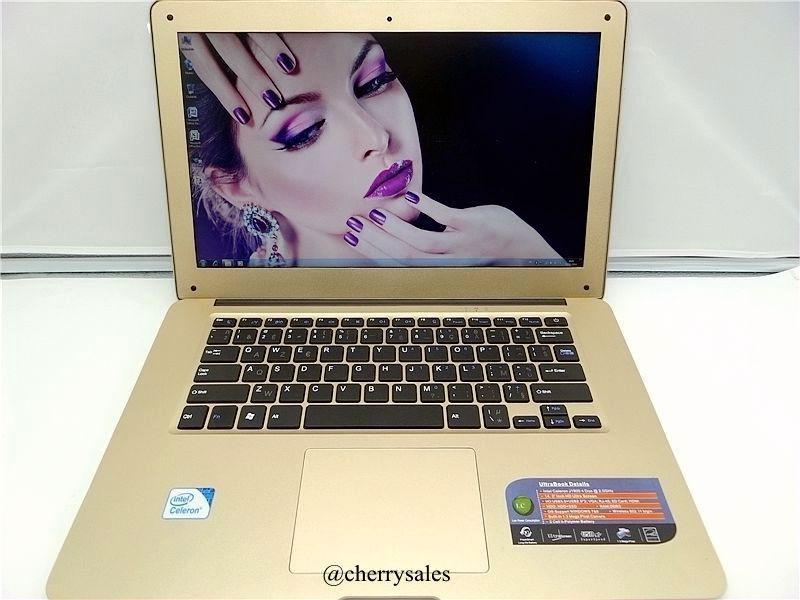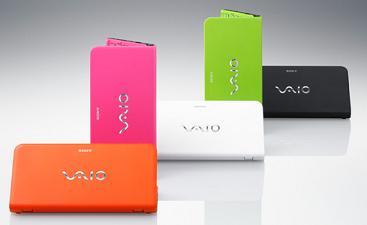The first image is the image on the left, the second image is the image on the right. Assess this claim about the two images: "An open gold-toned laptop computer is shown in one image.". Correct or not? Answer yes or no. Yes. The first image is the image on the left, the second image is the image on the right. Considering the images on both sides, is "One image shows a laptop with a woman's face predominant on the screen." valid? Answer yes or no. Yes. 